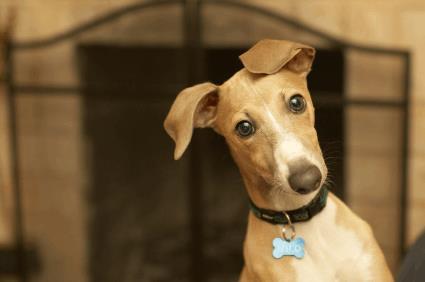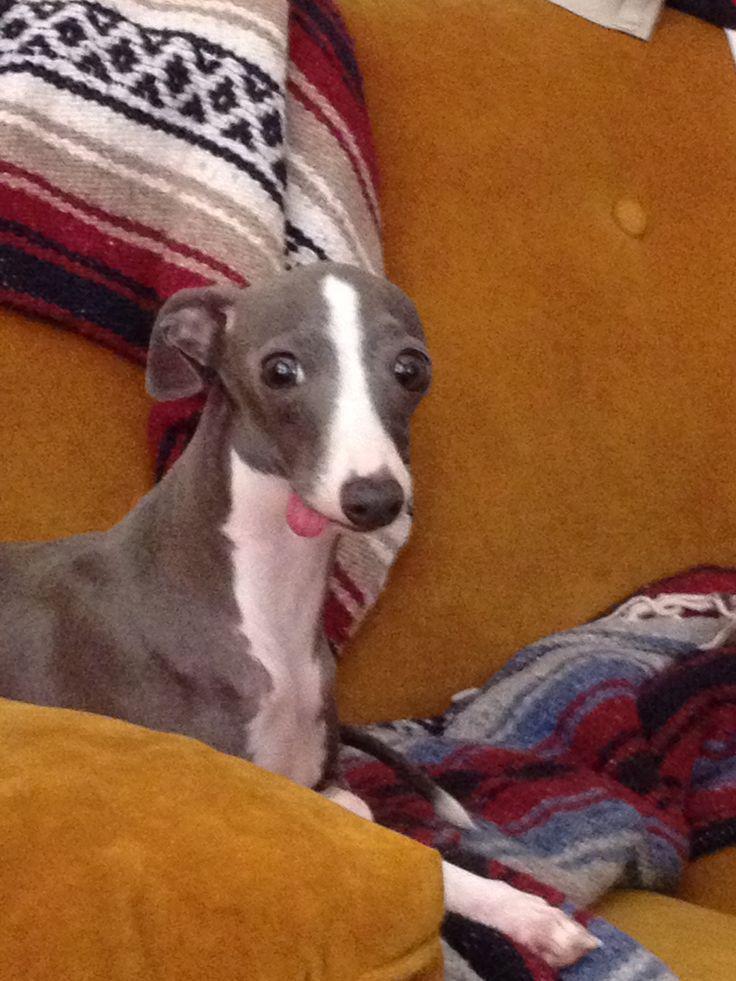The first image is the image on the left, the second image is the image on the right. Evaluate the accuracy of this statement regarding the images: "There is a dog posing near some green leaves.". Is it true? Answer yes or no. No. The first image is the image on the left, the second image is the image on the right. Analyze the images presented: Is the assertion "Each image contains a single dog, and all dogs are charcoal gray with white markings." valid? Answer yes or no. No. 